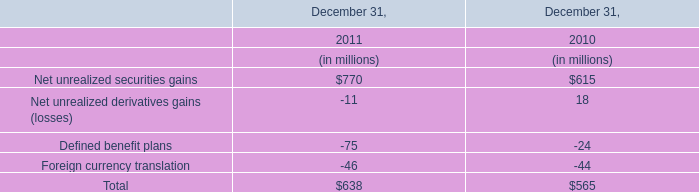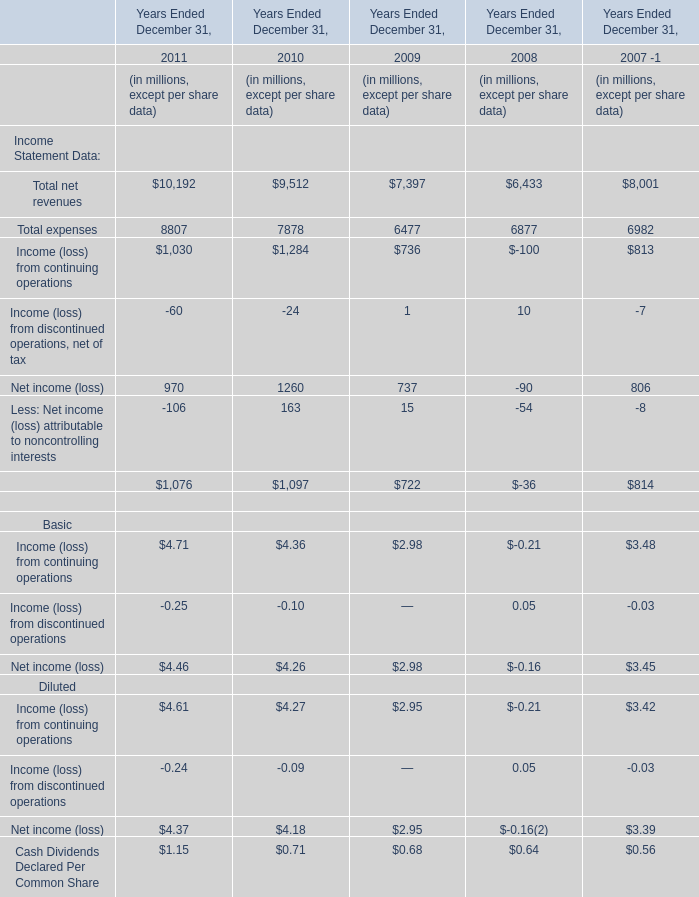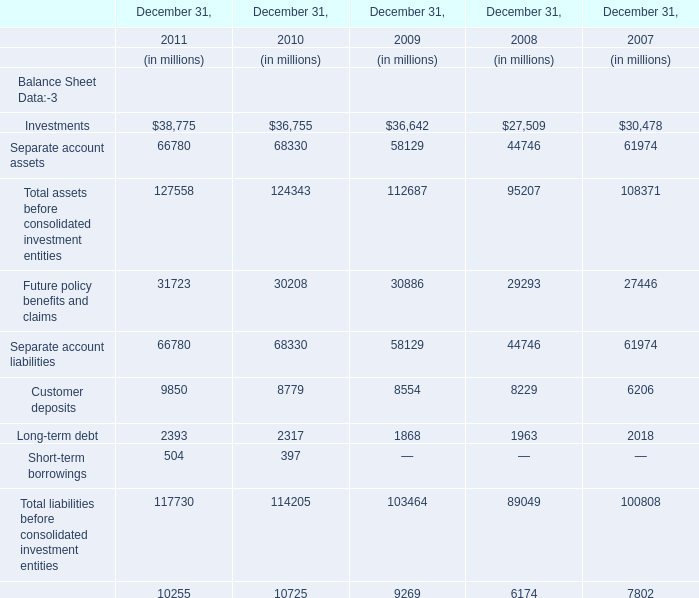What's the average of total expenses in 2011, 2010, and 2009? (in million) 
Computations: (((8807 + 7878) + 6477) / 3)
Answer: 7720.66667. 